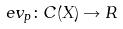Convert formula to latex. <formula><loc_0><loc_0><loc_500><loc_500>e v _ { p } \colon C ( X ) \rightarrow R</formula> 